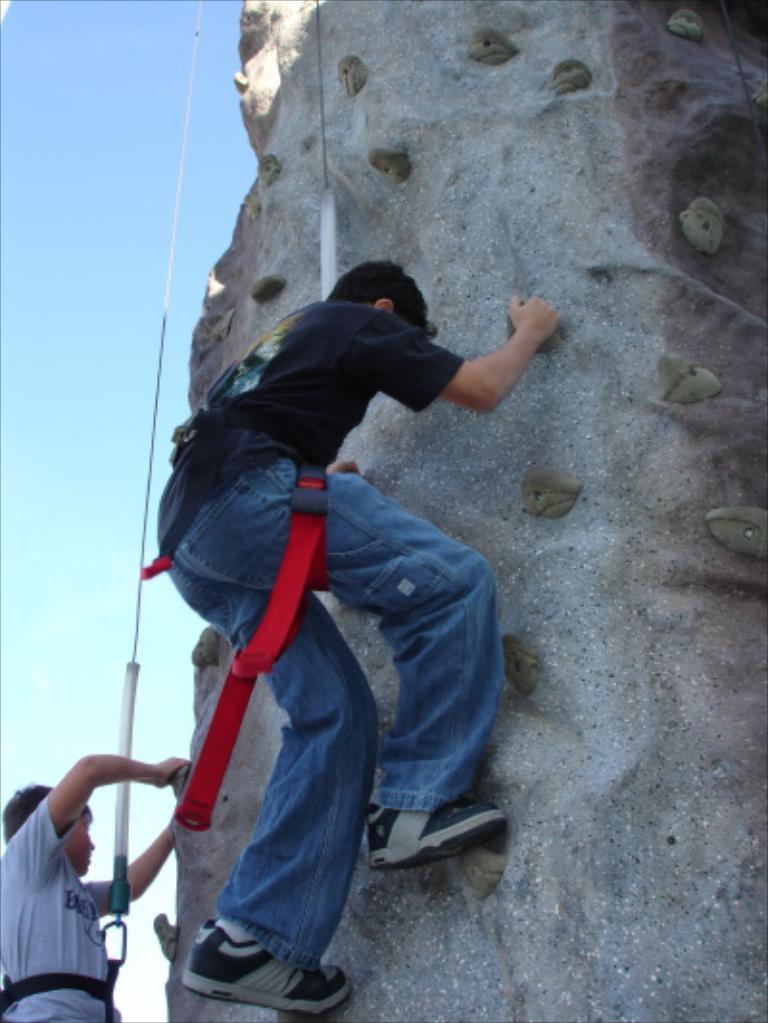How many people are in the foreground of the image? There are two persons in the foreground of the image. What are the persons doing in the image? The persons are climbing on a rock. What can be seen in the background of the image? There are ropes visible in the background of the image. What is visible in the sky in the image? The sky is visible in the image. Can you determine the time of day the image was taken? The image was likely taken during the day, as the sky is visible and there is sufficient light. What type of punishment is being administered to the sky in the image? There is no punishment being administered to the sky in the image; the sky is simply visible in the background. What does the taste of the rock being climbed by the persons in the image? The image does not convey any information about the taste of the rock. 